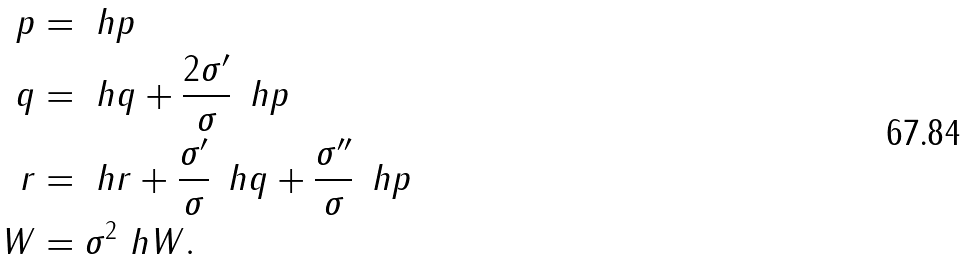Convert formula to latex. <formula><loc_0><loc_0><loc_500><loc_500>p & = \ h p \\ q & = \ h q + \frac { 2 \sigma ^ { \prime } } { \sigma } \, \ h p \\ r & = \ h r + \frac { \sigma ^ { \prime } } { \sigma } \, \ h q + \frac { \sigma ^ { \prime \prime } } { \sigma } \, \ h p \\ W & = \sigma ^ { 2 } \ h W .</formula> 